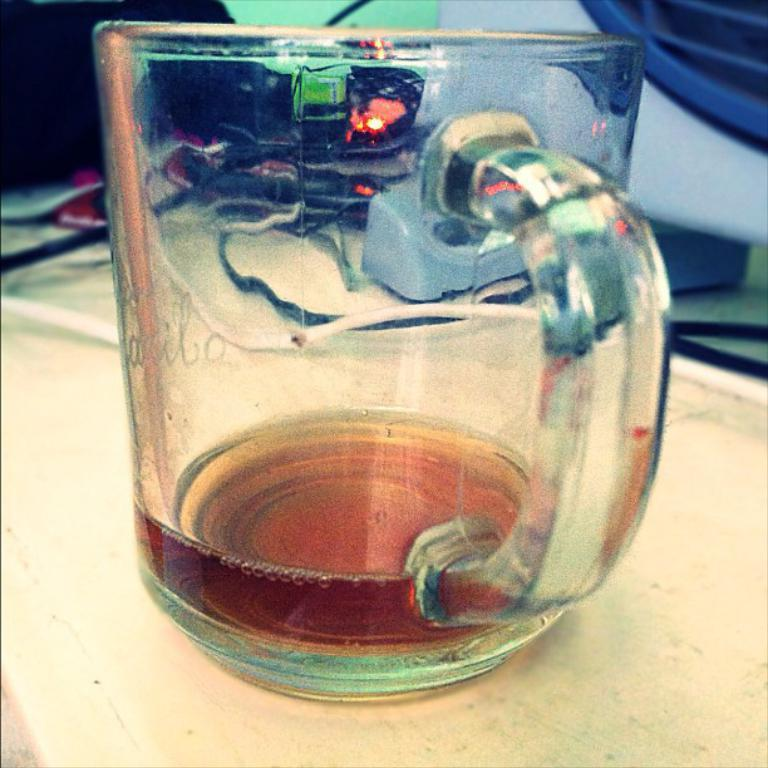What is located in the center of the image? There is a cup in the center of the image. Where is the cup placed? The cup is placed on a table. What else can be seen in the image besides the cup? There are wires visible in the image. What type of pin can be seen on the achiever's shirt in the image? There is no achiever or pin present in the image; it only features a cup and wires. 